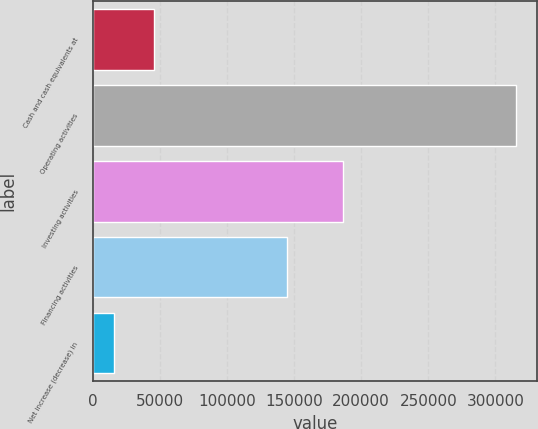Convert chart. <chart><loc_0><loc_0><loc_500><loc_500><bar_chart><fcel>Cash and cash equivalents at<fcel>Operating activities<fcel>Investing activities<fcel>Financing activities<fcel>Net increase (decrease) in<nl><fcel>45958.7<fcel>315164<fcel>186540<fcel>144671<fcel>16047<nl></chart> 